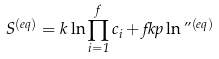<formula> <loc_0><loc_0><loc_500><loc_500>S ^ { ( e q ) } = k \ln \prod _ { i = 1 } ^ { f } c _ { i } + f k p \ln \varepsilon ^ { ( e q ) }</formula> 